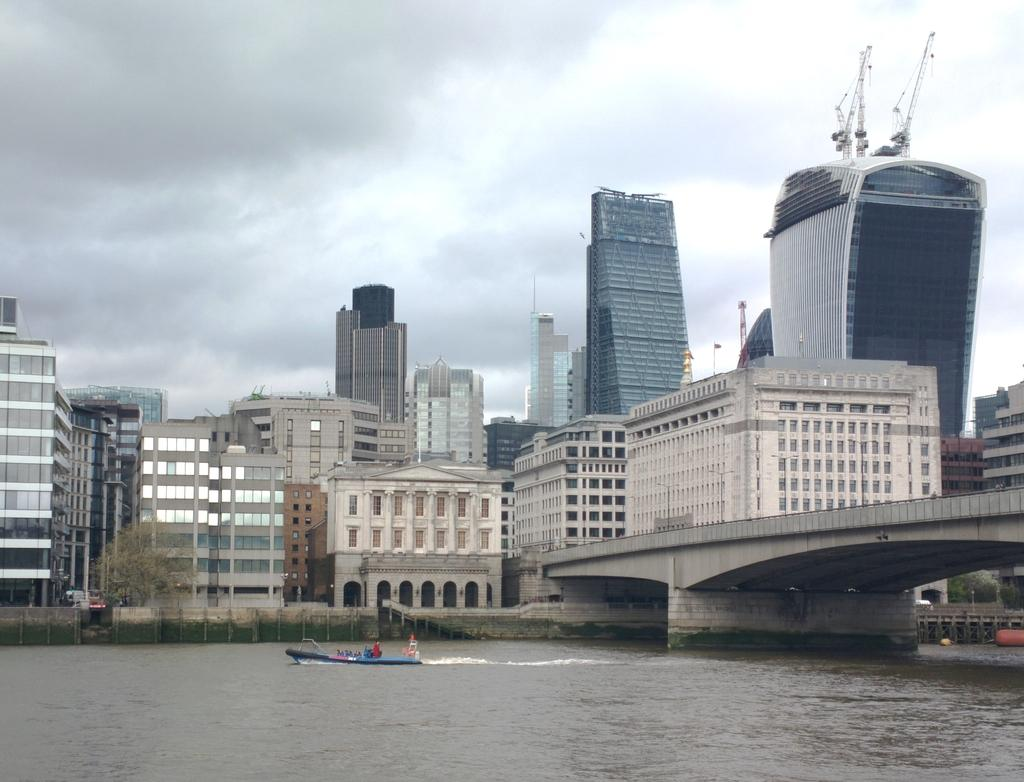What is the weather like in the image? The sky is cloudy in the image. What type of structures can be seen in the image? There are buildings in the image. What part of the buildings can be seen in the image? There are windows visible in the image. What is above the water in the image? There is a bridge and a boat above the water in the image. What type of vegetation is near a building in the image? There is a tree in front of a building in the image. Can you see a goose swimming in the lake in the image? There is no lake or goose present in the image. What color is the sock on the tree in the image? There is no sock present in the image. 